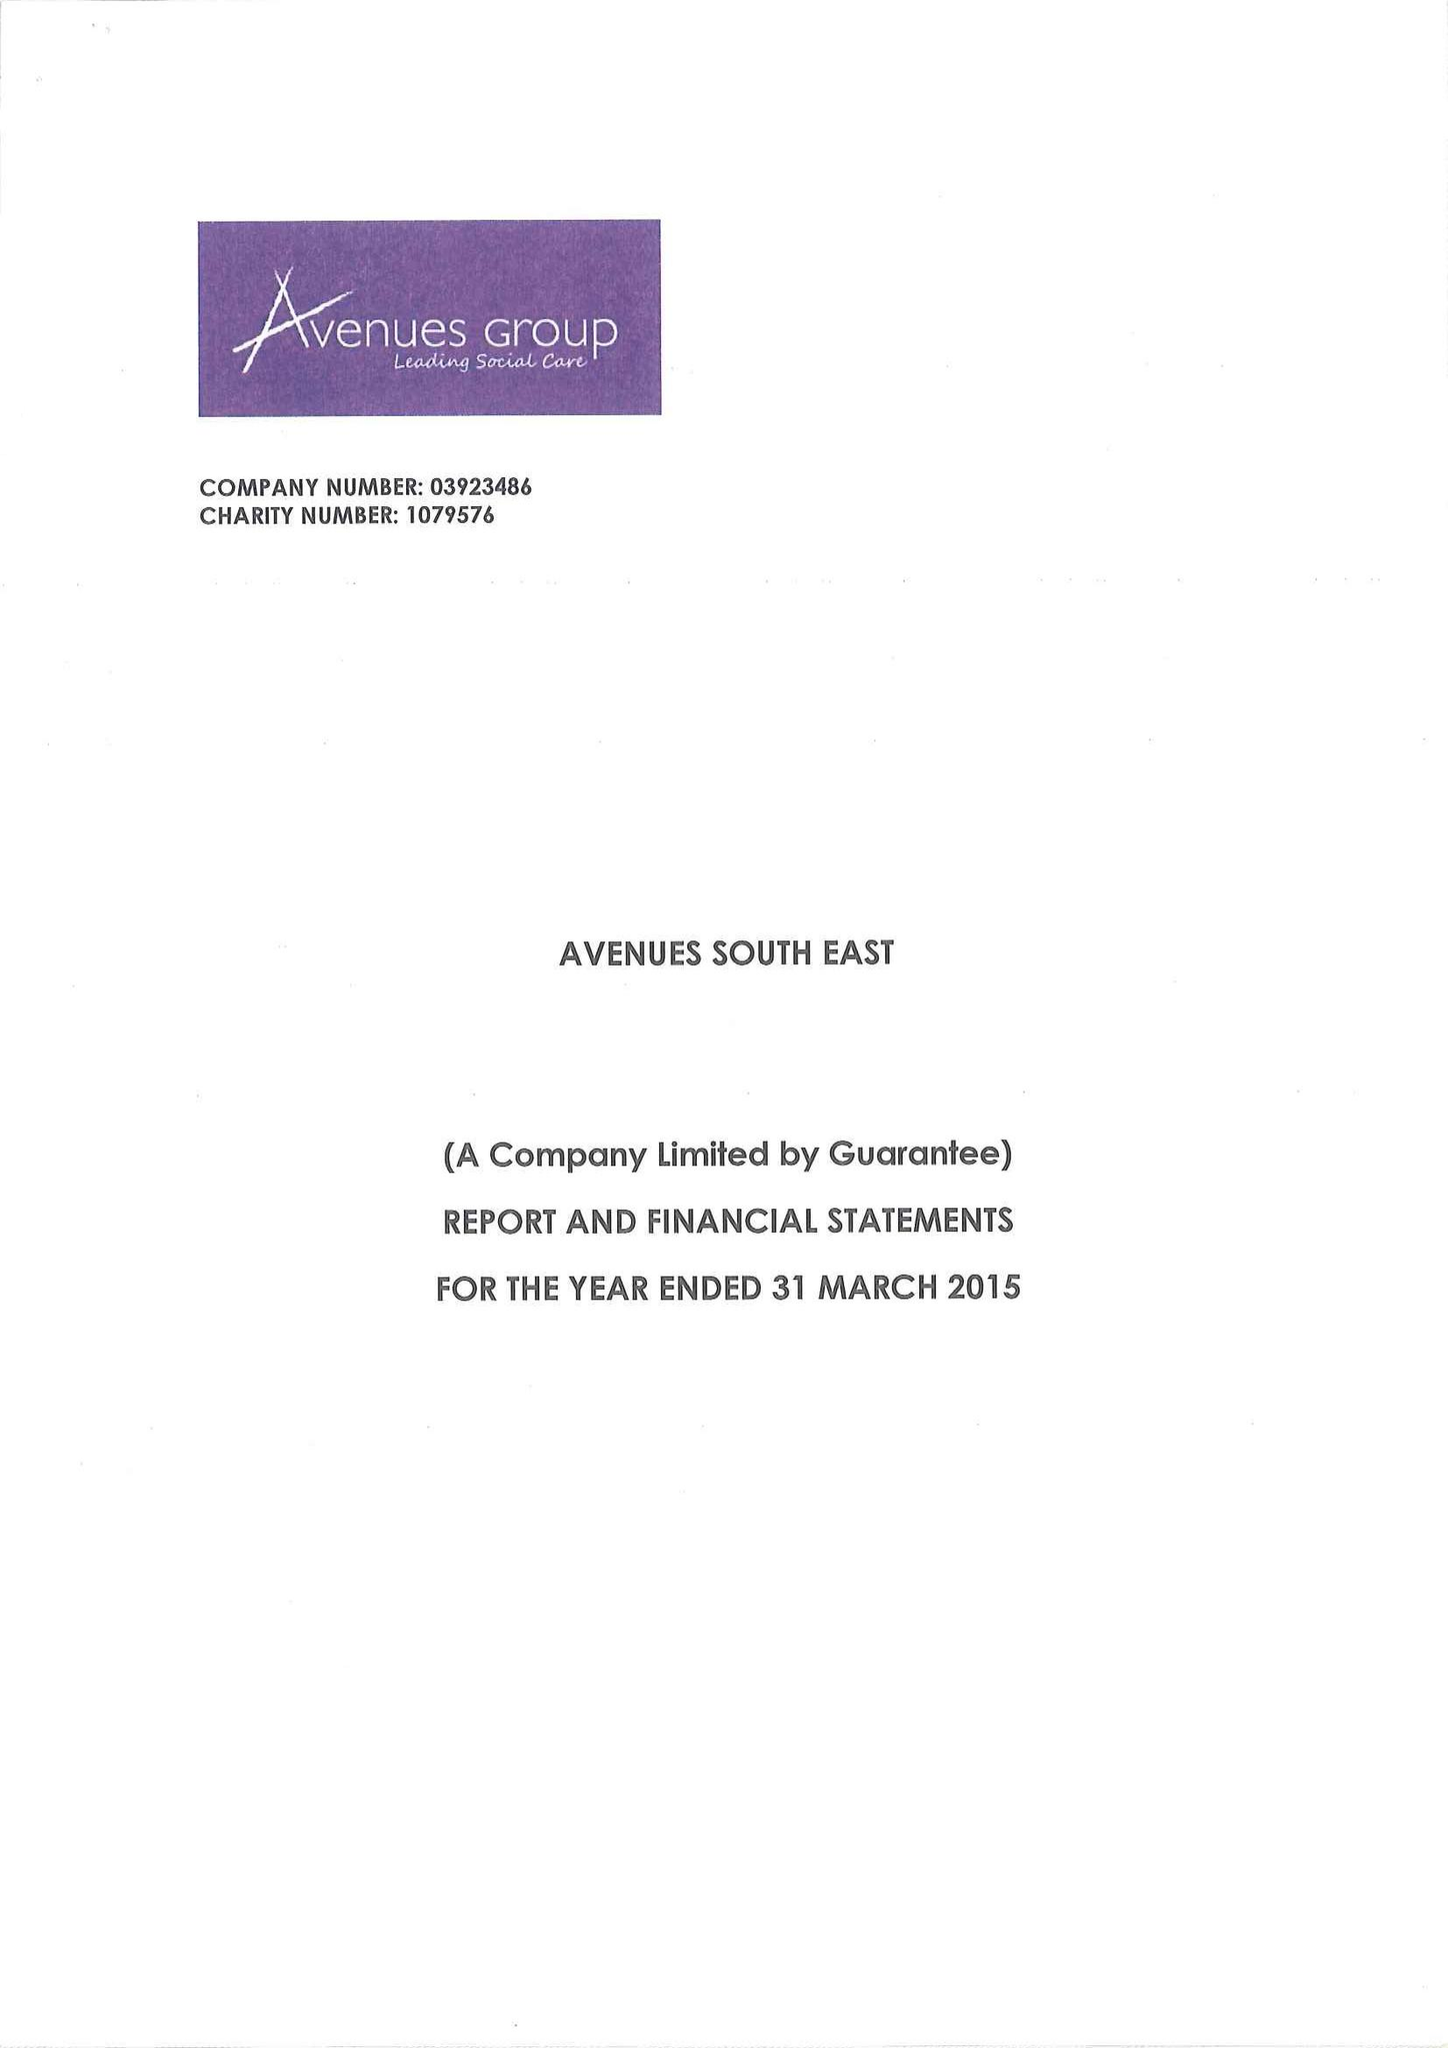What is the value for the address__street_line?
Answer the question using a single word or phrase. 1 MAIDSTONE ROAD 